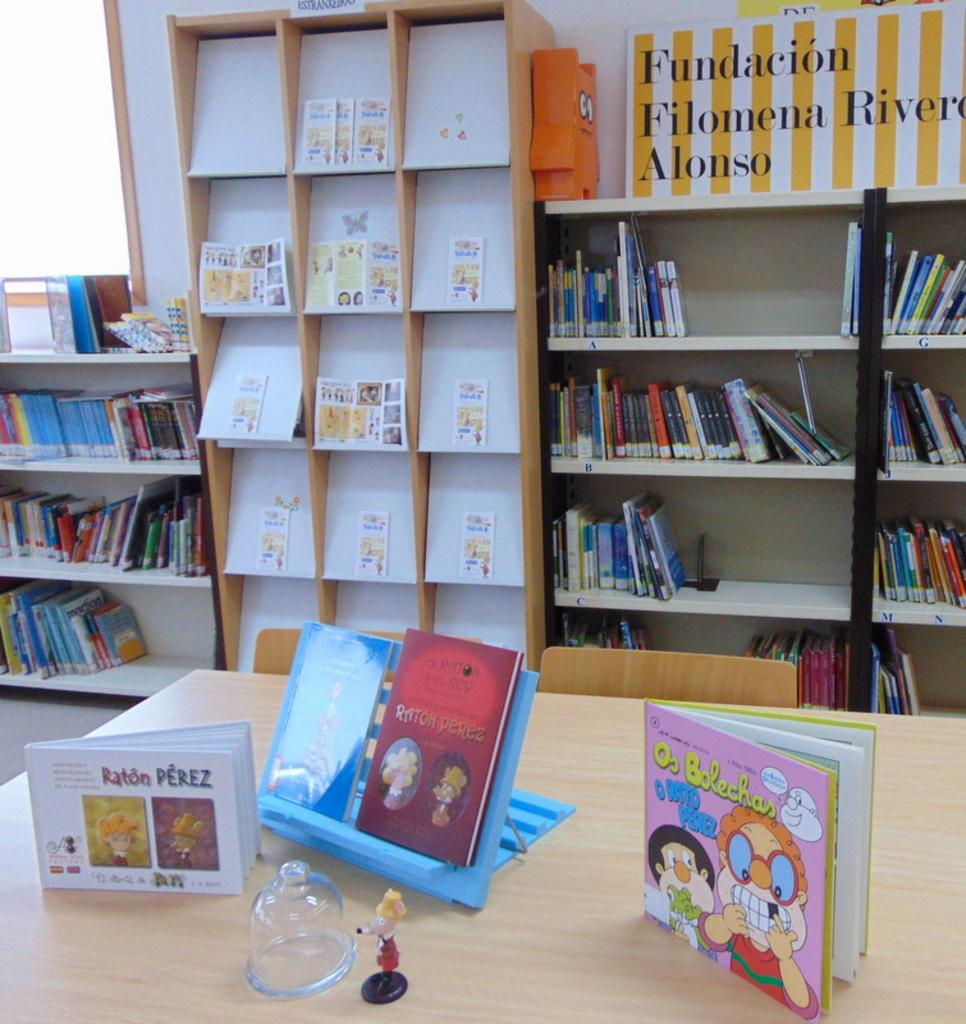What is the main piece of furniture in the image? There is a table in the image. What items can be seen on the table? There are books, a toy, a stand, and a glass object on the table. What can be seen on the shelves in the background? There are books on shelves in the background. What type of decorations are present in the background? There are posters in the background. Are there any other objects visible in the background? Yes, there are other objects visible in the background. Can you see a stream flowing through the town in the image? There is no stream or town visible in the image. What type of hand is holding the toy on the table? There is no hand visible in the image; only the toy is present on the table. 